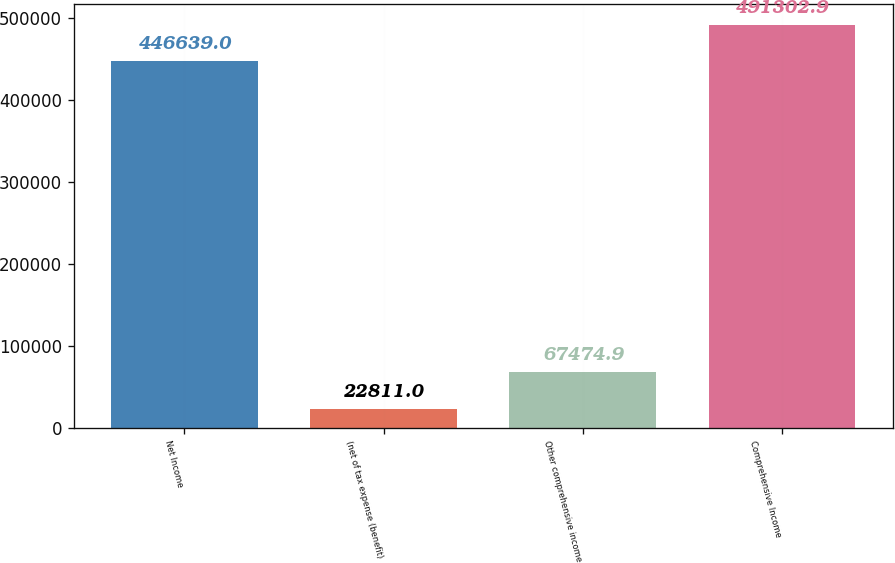<chart> <loc_0><loc_0><loc_500><loc_500><bar_chart><fcel>Net Income<fcel>(net of tax expense (benefit)<fcel>Other comprehensive income<fcel>Comprehensive Income<nl><fcel>446639<fcel>22811<fcel>67474.9<fcel>491303<nl></chart> 